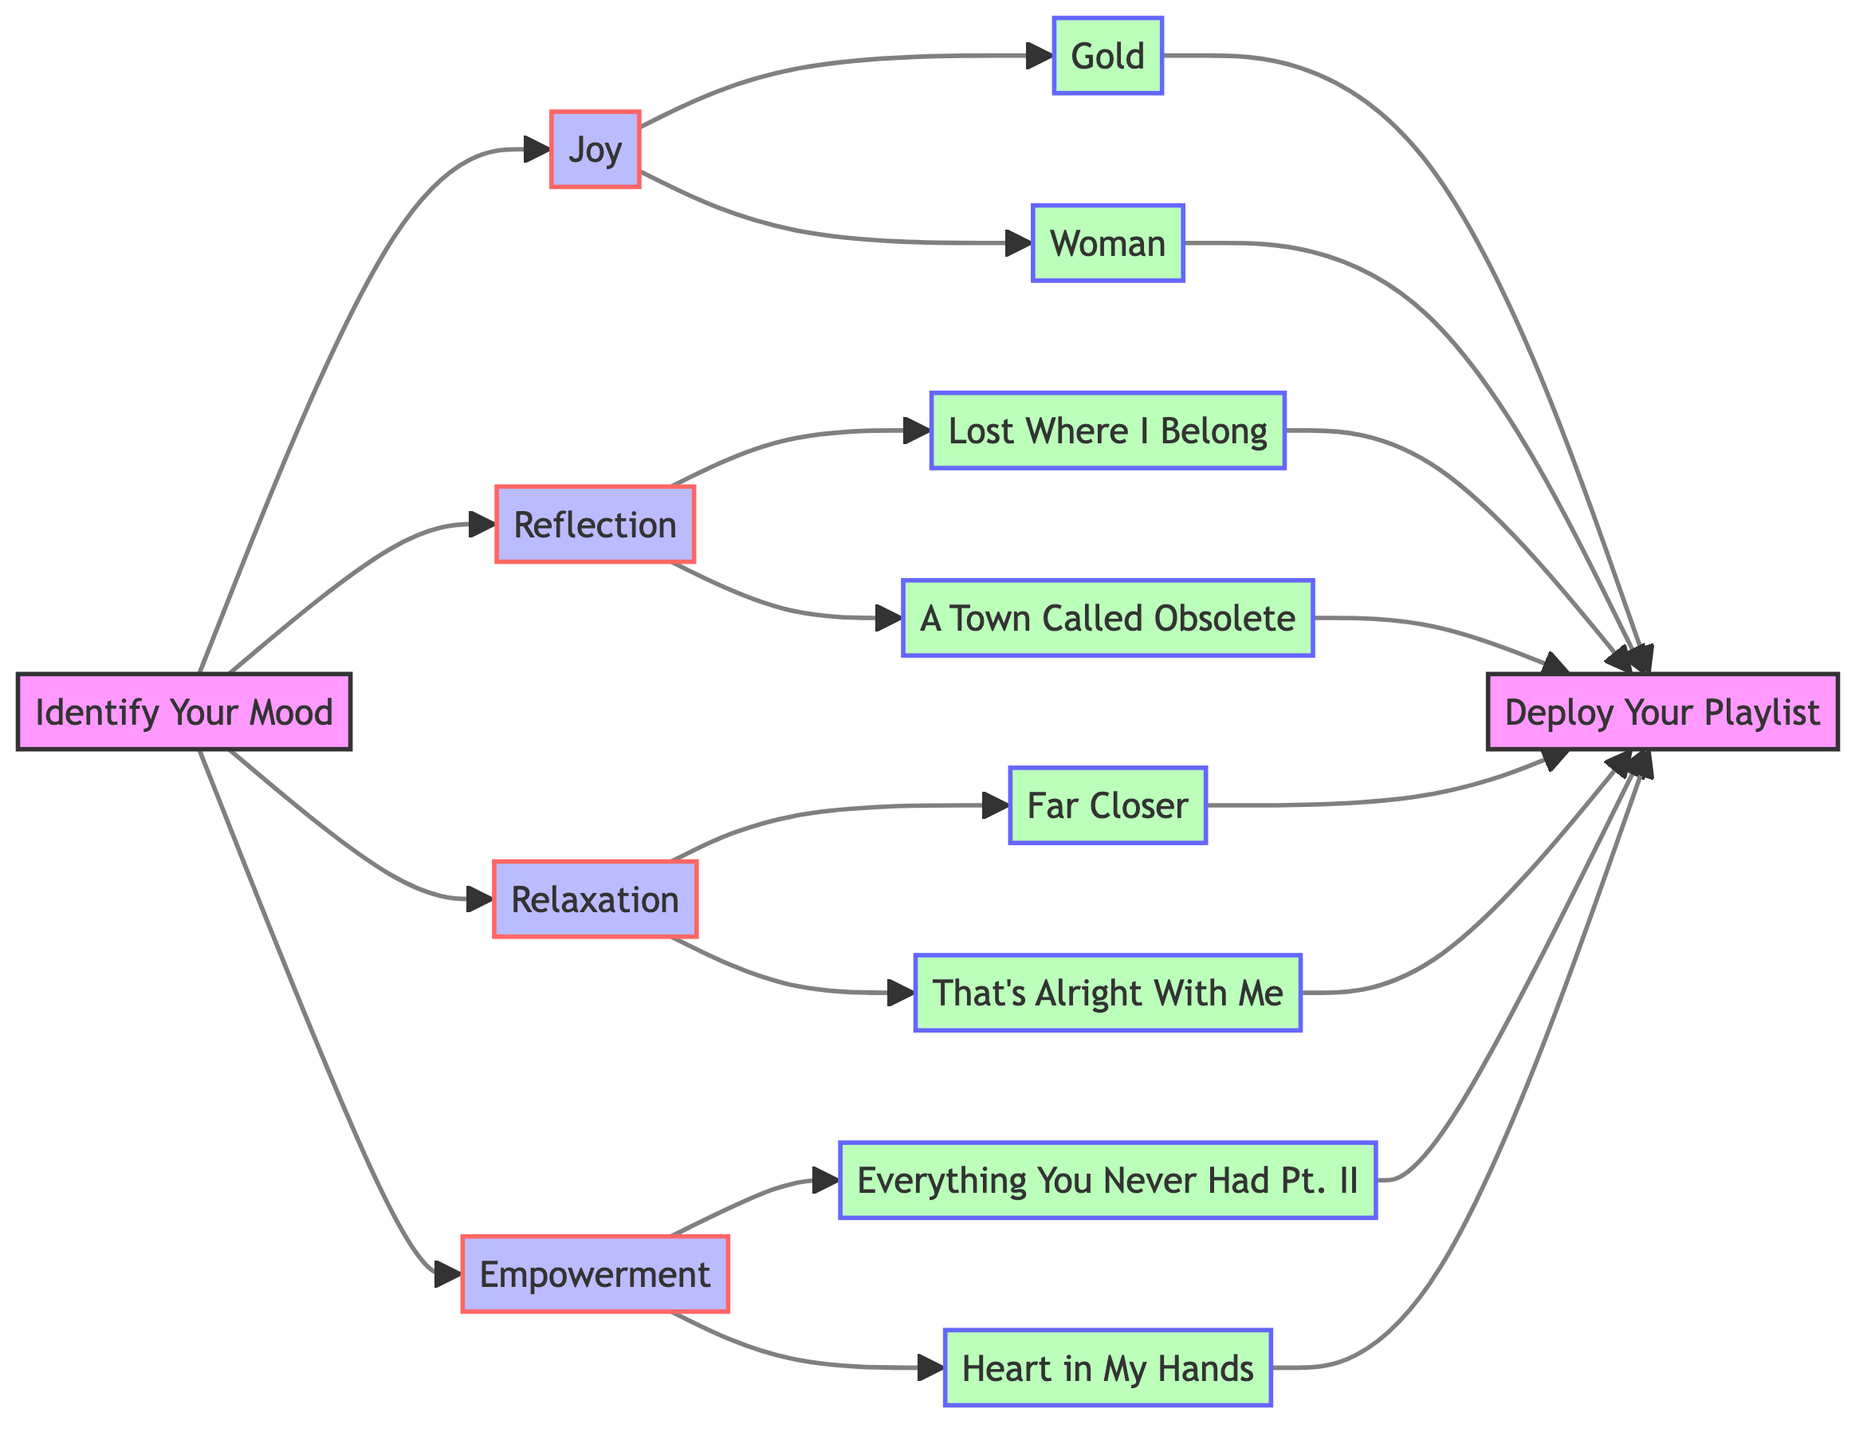What is the starting point of the flowchart? The flowchart begins with the node labeled "Identify Your Mood," indicating that the first step is to recognize one's mood before creating the playlist.
Answer: Identify Your Mood How many moods are depicted in the diagram? The diagram shows four distinct moods: Joy, Reflection, Relaxation, and Empowerment. Each mood corresponds to specific songs.
Answer: 4 What song is associated with the Joy mood? The Joy mood includes two songs, one of which is "Gold." This song is indicated as flowing from the Joy node in the diagram.
Answer: Gold Which mood is linked to the song "Lost Where I Belong"? "Lost Where I Belong" flows from the Reflection mood node, indicating that it is part of the reflective playlist.
Answer: Reflection Is the song "That's Alright With Me" associated with Relaxation or Empowerment? "That's Alright With Me" is connected to the Relaxation mood, as indicated by its direct link from the Relaxation node in the diagram.
Answer: Relaxation How many songs are listed under the Empowerment mood? The Empowerment mood features two songs, which are linked to it in the flowchart. I confirm this by checking the connections from the Empowerment node.
Answer: 2 What is the end point of the flowchart? The flowchart concludes with "Deploy Your Playlist," signifying that after selecting songs for your mood, the final step is to create the playlist.
Answer: Deploy Your Playlist Which mood has the song "Heart in My Hands"? "Heart in My Hands" is associated with the Empowerment mood, as shown by its connection to the Empowerment node in the diagram.
Answer: Empowerment What color represents the mood nodes in the diagram? The mood nodes, which include Joy, Reflection, Relaxation, and Empowerment, are colored blue in the diagram according to the class definition provided.
Answer: Blue 